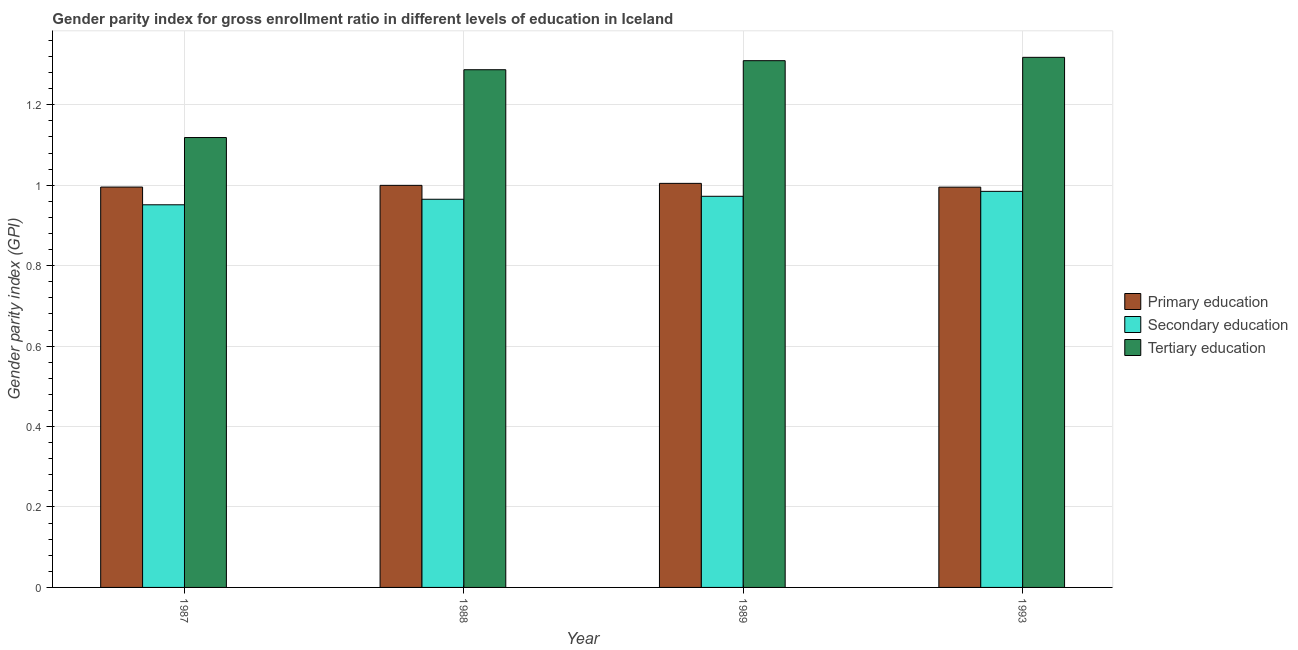How many different coloured bars are there?
Your answer should be very brief. 3. Are the number of bars on each tick of the X-axis equal?
Provide a succinct answer. Yes. How many bars are there on the 3rd tick from the left?
Give a very brief answer. 3. What is the label of the 3rd group of bars from the left?
Ensure brevity in your answer.  1989. In how many cases, is the number of bars for a given year not equal to the number of legend labels?
Offer a very short reply. 0. What is the gender parity index in tertiary education in 1993?
Your response must be concise. 1.32. Across all years, what is the maximum gender parity index in primary education?
Give a very brief answer. 1. Across all years, what is the minimum gender parity index in tertiary education?
Provide a short and direct response. 1.12. In which year was the gender parity index in tertiary education maximum?
Your answer should be very brief. 1993. What is the total gender parity index in tertiary education in the graph?
Ensure brevity in your answer.  5.03. What is the difference between the gender parity index in tertiary education in 1987 and that in 1989?
Offer a very short reply. -0.19. What is the difference between the gender parity index in secondary education in 1989 and the gender parity index in primary education in 1987?
Your answer should be compact. 0.02. What is the average gender parity index in secondary education per year?
Your answer should be compact. 0.97. In the year 1987, what is the difference between the gender parity index in secondary education and gender parity index in tertiary education?
Make the answer very short. 0. What is the ratio of the gender parity index in primary education in 1989 to that in 1993?
Your answer should be very brief. 1.01. Is the gender parity index in primary education in 1987 less than that in 1993?
Provide a succinct answer. No. Is the difference between the gender parity index in primary education in 1988 and 1989 greater than the difference between the gender parity index in secondary education in 1988 and 1989?
Your response must be concise. No. What is the difference between the highest and the second highest gender parity index in primary education?
Make the answer very short. 0. What is the difference between the highest and the lowest gender parity index in secondary education?
Your answer should be very brief. 0.03. In how many years, is the gender parity index in tertiary education greater than the average gender parity index in tertiary education taken over all years?
Provide a succinct answer. 3. Is the sum of the gender parity index in secondary education in 1987 and 1989 greater than the maximum gender parity index in tertiary education across all years?
Keep it short and to the point. Yes. What does the 2nd bar from the left in 1988 represents?
Your answer should be compact. Secondary education. What does the 1st bar from the right in 1987 represents?
Provide a short and direct response. Tertiary education. How many years are there in the graph?
Your answer should be very brief. 4. What is the difference between two consecutive major ticks on the Y-axis?
Offer a very short reply. 0.2. Are the values on the major ticks of Y-axis written in scientific E-notation?
Offer a terse response. No. Does the graph contain any zero values?
Your answer should be very brief. No. Where does the legend appear in the graph?
Your response must be concise. Center right. How many legend labels are there?
Keep it short and to the point. 3. How are the legend labels stacked?
Offer a terse response. Vertical. What is the title of the graph?
Your answer should be very brief. Gender parity index for gross enrollment ratio in different levels of education in Iceland. Does "Czech Republic" appear as one of the legend labels in the graph?
Offer a very short reply. No. What is the label or title of the X-axis?
Offer a terse response. Year. What is the label or title of the Y-axis?
Your answer should be compact. Gender parity index (GPI). What is the Gender parity index (GPI) in Primary education in 1987?
Provide a short and direct response. 1. What is the Gender parity index (GPI) of Secondary education in 1987?
Your answer should be very brief. 0.95. What is the Gender parity index (GPI) in Tertiary education in 1987?
Your response must be concise. 1.12. What is the Gender parity index (GPI) of Primary education in 1988?
Provide a succinct answer. 1. What is the Gender parity index (GPI) of Secondary education in 1988?
Give a very brief answer. 0.97. What is the Gender parity index (GPI) in Tertiary education in 1988?
Offer a very short reply. 1.29. What is the Gender parity index (GPI) in Primary education in 1989?
Your response must be concise. 1. What is the Gender parity index (GPI) in Secondary education in 1989?
Offer a very short reply. 0.97. What is the Gender parity index (GPI) in Tertiary education in 1989?
Your response must be concise. 1.31. What is the Gender parity index (GPI) in Secondary education in 1993?
Provide a succinct answer. 0.98. What is the Gender parity index (GPI) of Tertiary education in 1993?
Offer a very short reply. 1.32. Across all years, what is the maximum Gender parity index (GPI) of Primary education?
Your answer should be very brief. 1. Across all years, what is the maximum Gender parity index (GPI) in Secondary education?
Offer a very short reply. 0.98. Across all years, what is the maximum Gender parity index (GPI) in Tertiary education?
Keep it short and to the point. 1.32. Across all years, what is the minimum Gender parity index (GPI) in Primary education?
Your answer should be very brief. 1. Across all years, what is the minimum Gender parity index (GPI) of Secondary education?
Provide a short and direct response. 0.95. Across all years, what is the minimum Gender parity index (GPI) of Tertiary education?
Make the answer very short. 1.12. What is the total Gender parity index (GPI) of Primary education in the graph?
Keep it short and to the point. 4. What is the total Gender parity index (GPI) of Secondary education in the graph?
Your response must be concise. 3.87. What is the total Gender parity index (GPI) of Tertiary education in the graph?
Offer a very short reply. 5.03. What is the difference between the Gender parity index (GPI) of Primary education in 1987 and that in 1988?
Keep it short and to the point. -0. What is the difference between the Gender parity index (GPI) of Secondary education in 1987 and that in 1988?
Provide a succinct answer. -0.01. What is the difference between the Gender parity index (GPI) of Tertiary education in 1987 and that in 1988?
Give a very brief answer. -0.17. What is the difference between the Gender parity index (GPI) of Primary education in 1987 and that in 1989?
Give a very brief answer. -0.01. What is the difference between the Gender parity index (GPI) in Secondary education in 1987 and that in 1989?
Your response must be concise. -0.02. What is the difference between the Gender parity index (GPI) of Tertiary education in 1987 and that in 1989?
Your answer should be compact. -0.19. What is the difference between the Gender parity index (GPI) of Secondary education in 1987 and that in 1993?
Make the answer very short. -0.03. What is the difference between the Gender parity index (GPI) of Tertiary education in 1987 and that in 1993?
Your response must be concise. -0.2. What is the difference between the Gender parity index (GPI) of Primary education in 1988 and that in 1989?
Give a very brief answer. -0. What is the difference between the Gender parity index (GPI) of Secondary education in 1988 and that in 1989?
Your response must be concise. -0.01. What is the difference between the Gender parity index (GPI) in Tertiary education in 1988 and that in 1989?
Your answer should be compact. -0.02. What is the difference between the Gender parity index (GPI) in Primary education in 1988 and that in 1993?
Ensure brevity in your answer.  0. What is the difference between the Gender parity index (GPI) of Secondary education in 1988 and that in 1993?
Your answer should be compact. -0.02. What is the difference between the Gender parity index (GPI) in Tertiary education in 1988 and that in 1993?
Provide a short and direct response. -0.03. What is the difference between the Gender parity index (GPI) of Primary education in 1989 and that in 1993?
Provide a succinct answer. 0.01. What is the difference between the Gender parity index (GPI) of Secondary education in 1989 and that in 1993?
Ensure brevity in your answer.  -0.01. What is the difference between the Gender parity index (GPI) in Tertiary education in 1989 and that in 1993?
Keep it short and to the point. -0.01. What is the difference between the Gender parity index (GPI) of Primary education in 1987 and the Gender parity index (GPI) of Secondary education in 1988?
Give a very brief answer. 0.03. What is the difference between the Gender parity index (GPI) of Primary education in 1987 and the Gender parity index (GPI) of Tertiary education in 1988?
Offer a terse response. -0.29. What is the difference between the Gender parity index (GPI) in Secondary education in 1987 and the Gender parity index (GPI) in Tertiary education in 1988?
Your answer should be very brief. -0.34. What is the difference between the Gender parity index (GPI) of Primary education in 1987 and the Gender parity index (GPI) of Secondary education in 1989?
Keep it short and to the point. 0.02. What is the difference between the Gender parity index (GPI) of Primary education in 1987 and the Gender parity index (GPI) of Tertiary education in 1989?
Make the answer very short. -0.31. What is the difference between the Gender parity index (GPI) of Secondary education in 1987 and the Gender parity index (GPI) of Tertiary education in 1989?
Your answer should be compact. -0.36. What is the difference between the Gender parity index (GPI) of Primary education in 1987 and the Gender parity index (GPI) of Secondary education in 1993?
Your answer should be very brief. 0.01. What is the difference between the Gender parity index (GPI) in Primary education in 1987 and the Gender parity index (GPI) in Tertiary education in 1993?
Your answer should be compact. -0.32. What is the difference between the Gender parity index (GPI) of Secondary education in 1987 and the Gender parity index (GPI) of Tertiary education in 1993?
Provide a succinct answer. -0.37. What is the difference between the Gender parity index (GPI) of Primary education in 1988 and the Gender parity index (GPI) of Secondary education in 1989?
Provide a succinct answer. 0.03. What is the difference between the Gender parity index (GPI) in Primary education in 1988 and the Gender parity index (GPI) in Tertiary education in 1989?
Make the answer very short. -0.31. What is the difference between the Gender parity index (GPI) in Secondary education in 1988 and the Gender parity index (GPI) in Tertiary education in 1989?
Your response must be concise. -0.34. What is the difference between the Gender parity index (GPI) of Primary education in 1988 and the Gender parity index (GPI) of Secondary education in 1993?
Your response must be concise. 0.01. What is the difference between the Gender parity index (GPI) of Primary education in 1988 and the Gender parity index (GPI) of Tertiary education in 1993?
Give a very brief answer. -0.32. What is the difference between the Gender parity index (GPI) of Secondary education in 1988 and the Gender parity index (GPI) of Tertiary education in 1993?
Offer a very short reply. -0.35. What is the difference between the Gender parity index (GPI) of Primary education in 1989 and the Gender parity index (GPI) of Secondary education in 1993?
Your response must be concise. 0.02. What is the difference between the Gender parity index (GPI) of Primary education in 1989 and the Gender parity index (GPI) of Tertiary education in 1993?
Your answer should be very brief. -0.31. What is the difference between the Gender parity index (GPI) in Secondary education in 1989 and the Gender parity index (GPI) in Tertiary education in 1993?
Make the answer very short. -0.35. What is the average Gender parity index (GPI) of Primary education per year?
Give a very brief answer. 1. What is the average Gender parity index (GPI) of Secondary education per year?
Your response must be concise. 0.97. What is the average Gender parity index (GPI) of Tertiary education per year?
Offer a very short reply. 1.26. In the year 1987, what is the difference between the Gender parity index (GPI) in Primary education and Gender parity index (GPI) in Secondary education?
Keep it short and to the point. 0.04. In the year 1987, what is the difference between the Gender parity index (GPI) of Primary education and Gender parity index (GPI) of Tertiary education?
Your answer should be very brief. -0.12. In the year 1987, what is the difference between the Gender parity index (GPI) of Secondary education and Gender parity index (GPI) of Tertiary education?
Give a very brief answer. -0.17. In the year 1988, what is the difference between the Gender parity index (GPI) of Primary education and Gender parity index (GPI) of Secondary education?
Your response must be concise. 0.03. In the year 1988, what is the difference between the Gender parity index (GPI) of Primary education and Gender parity index (GPI) of Tertiary education?
Your response must be concise. -0.29. In the year 1988, what is the difference between the Gender parity index (GPI) in Secondary education and Gender parity index (GPI) in Tertiary education?
Offer a very short reply. -0.32. In the year 1989, what is the difference between the Gender parity index (GPI) in Primary education and Gender parity index (GPI) in Secondary education?
Provide a short and direct response. 0.03. In the year 1989, what is the difference between the Gender parity index (GPI) in Primary education and Gender parity index (GPI) in Tertiary education?
Give a very brief answer. -0.31. In the year 1989, what is the difference between the Gender parity index (GPI) in Secondary education and Gender parity index (GPI) in Tertiary education?
Offer a terse response. -0.34. In the year 1993, what is the difference between the Gender parity index (GPI) in Primary education and Gender parity index (GPI) in Secondary education?
Your answer should be very brief. 0.01. In the year 1993, what is the difference between the Gender parity index (GPI) in Primary education and Gender parity index (GPI) in Tertiary education?
Your answer should be very brief. -0.32. In the year 1993, what is the difference between the Gender parity index (GPI) of Secondary education and Gender parity index (GPI) of Tertiary education?
Your answer should be very brief. -0.33. What is the ratio of the Gender parity index (GPI) of Primary education in 1987 to that in 1988?
Your answer should be compact. 1. What is the ratio of the Gender parity index (GPI) of Secondary education in 1987 to that in 1988?
Your response must be concise. 0.99. What is the ratio of the Gender parity index (GPI) of Tertiary education in 1987 to that in 1988?
Ensure brevity in your answer.  0.87. What is the ratio of the Gender parity index (GPI) of Primary education in 1987 to that in 1989?
Provide a short and direct response. 0.99. What is the ratio of the Gender parity index (GPI) in Secondary education in 1987 to that in 1989?
Offer a very short reply. 0.98. What is the ratio of the Gender parity index (GPI) in Tertiary education in 1987 to that in 1989?
Make the answer very short. 0.85. What is the ratio of the Gender parity index (GPI) of Secondary education in 1987 to that in 1993?
Provide a short and direct response. 0.97. What is the ratio of the Gender parity index (GPI) in Tertiary education in 1987 to that in 1993?
Ensure brevity in your answer.  0.85. What is the ratio of the Gender parity index (GPI) of Secondary education in 1988 to that in 1989?
Offer a very short reply. 0.99. What is the ratio of the Gender parity index (GPI) of Tertiary education in 1988 to that in 1989?
Your response must be concise. 0.98. What is the ratio of the Gender parity index (GPI) of Primary education in 1988 to that in 1993?
Give a very brief answer. 1. What is the ratio of the Gender parity index (GPI) in Tertiary education in 1988 to that in 1993?
Your answer should be compact. 0.98. What is the ratio of the Gender parity index (GPI) of Primary education in 1989 to that in 1993?
Make the answer very short. 1.01. What is the ratio of the Gender parity index (GPI) in Secondary education in 1989 to that in 1993?
Offer a very short reply. 0.99. What is the ratio of the Gender parity index (GPI) of Tertiary education in 1989 to that in 1993?
Ensure brevity in your answer.  0.99. What is the difference between the highest and the second highest Gender parity index (GPI) of Primary education?
Give a very brief answer. 0. What is the difference between the highest and the second highest Gender parity index (GPI) in Secondary education?
Your answer should be compact. 0.01. What is the difference between the highest and the second highest Gender parity index (GPI) of Tertiary education?
Your answer should be very brief. 0.01. What is the difference between the highest and the lowest Gender parity index (GPI) of Primary education?
Keep it short and to the point. 0.01. What is the difference between the highest and the lowest Gender parity index (GPI) of Secondary education?
Ensure brevity in your answer.  0.03. What is the difference between the highest and the lowest Gender parity index (GPI) of Tertiary education?
Your answer should be compact. 0.2. 